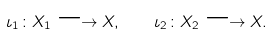Convert formula to latex. <formula><loc_0><loc_0><loc_500><loc_500>\iota _ { 1 } \colon X _ { 1 } \longrightarrow X , \quad \iota _ { 2 } \colon X _ { 2 } \longrightarrow X .</formula> 